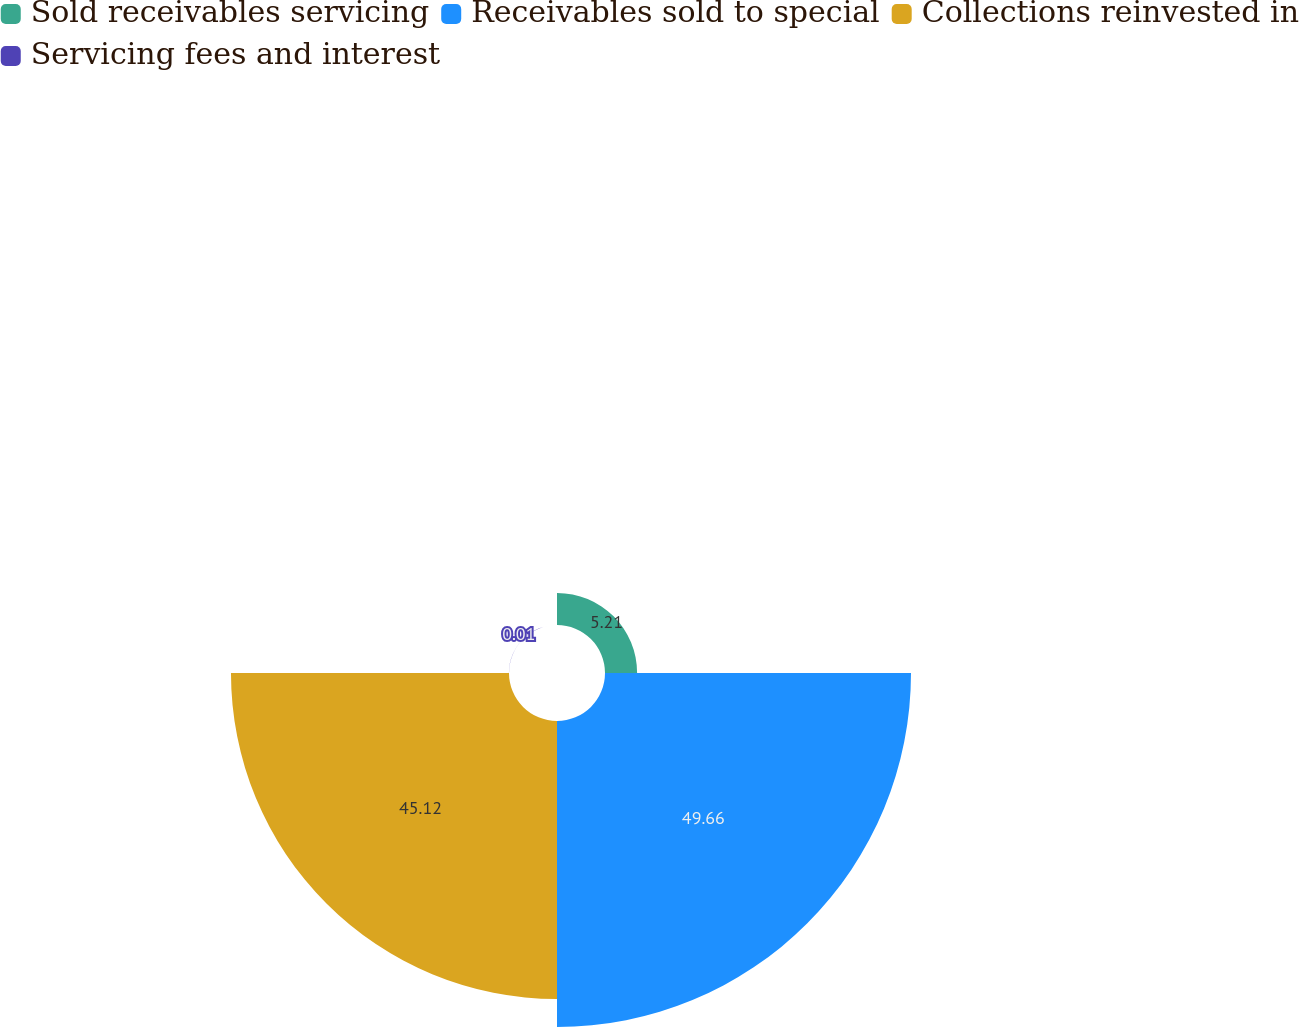<chart> <loc_0><loc_0><loc_500><loc_500><pie_chart><fcel>Sold receivables servicing<fcel>Receivables sold to special<fcel>Collections reinvested in<fcel>Servicing fees and interest<nl><fcel>5.21%<fcel>49.66%<fcel>45.12%<fcel>0.01%<nl></chart> 